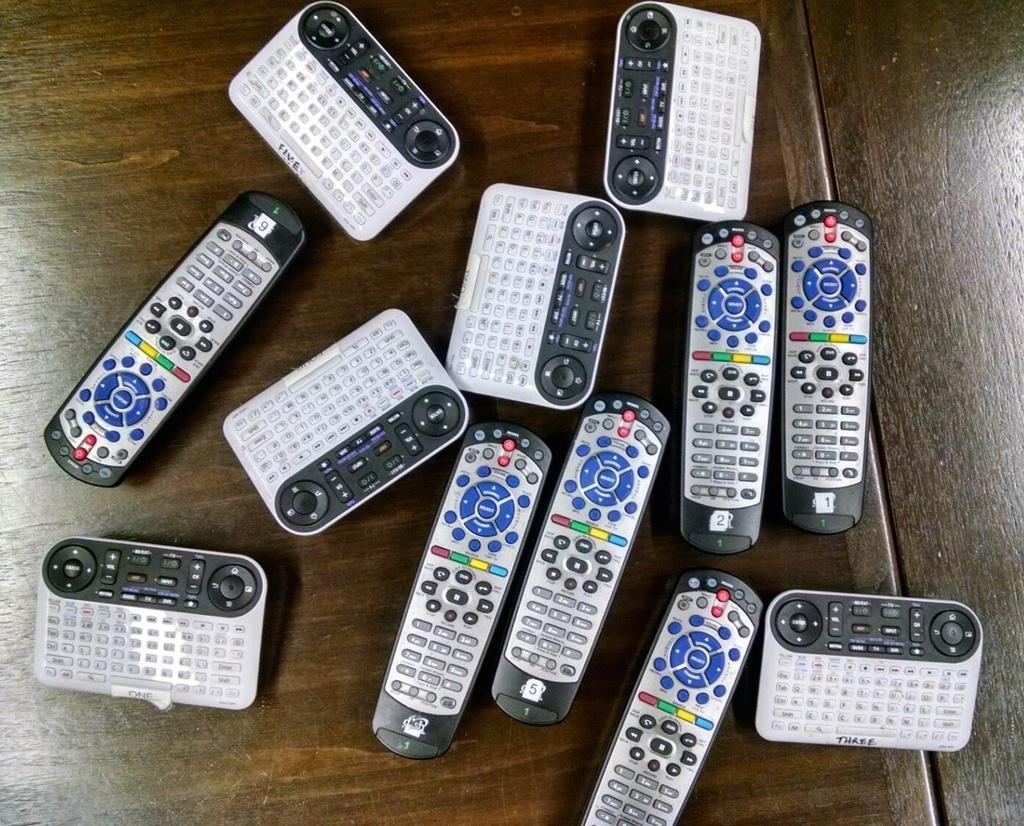Provide a one-sentence caption for the provided image. A pile of remotes with blue, green, red, and yellow buttons and labeled three. 